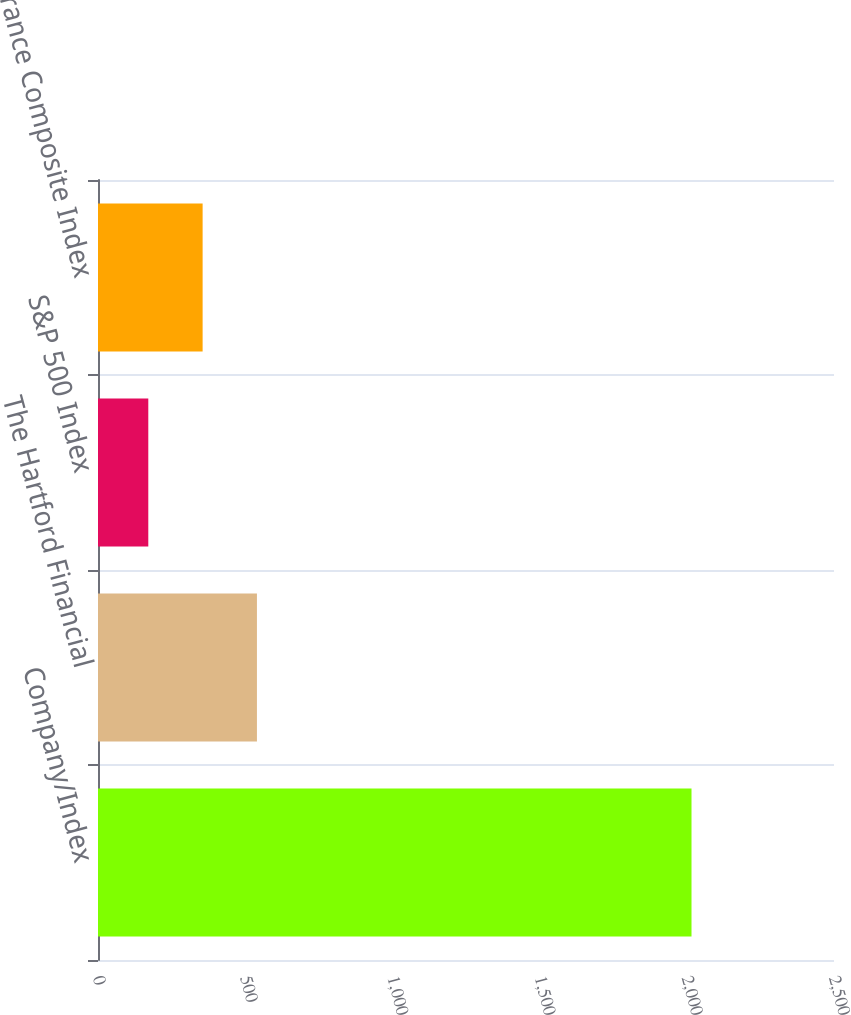Convert chart. <chart><loc_0><loc_0><loc_500><loc_500><bar_chart><fcel>Company/Index<fcel>The Hartford Financial<fcel>S&P 500 Index<fcel>S&P Insurance Composite Index<nl><fcel>2016<fcel>539.88<fcel>170.84<fcel>355.36<nl></chart> 